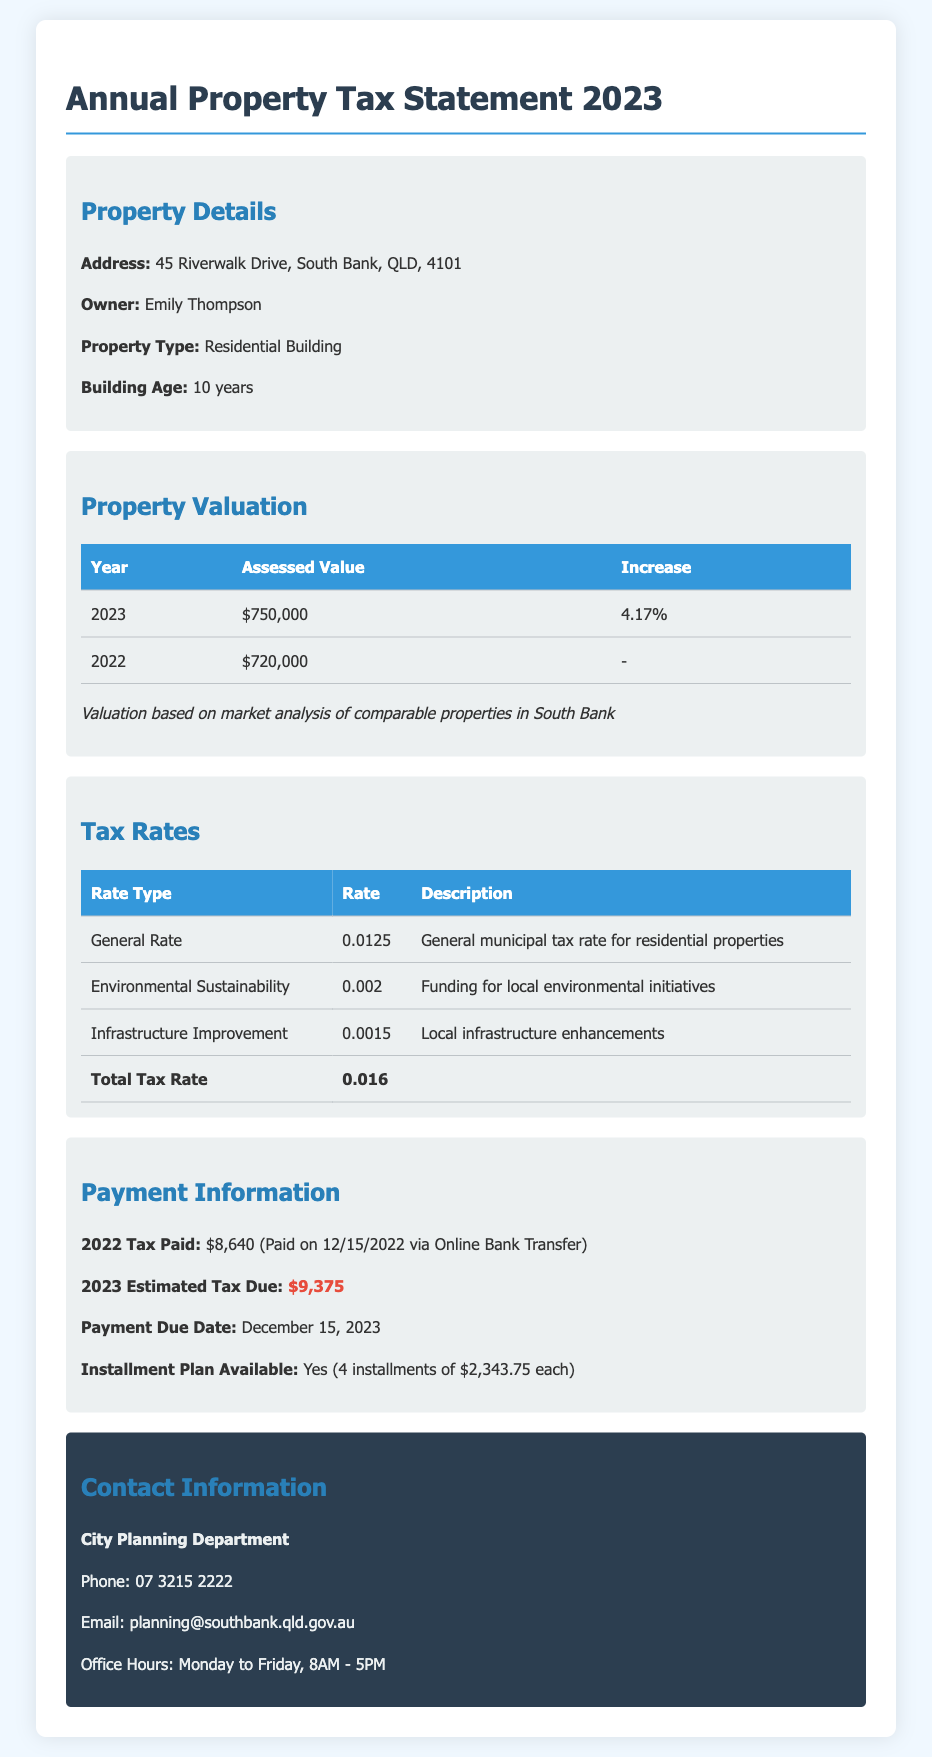What is the address of the property? The address is listed in the property details section.
Answer: 45 Riverwalk Drive, South Bank, QLD, 4101 Who is the owner of the property? The owner's name is mentioned in the property details section.
Answer: Emily Thompson What was the assessed value in 2023? The assessed value for 2023 is provided in the valuation table.
Answer: $750,000 What is the total tax rate? The total tax rate is summarized in the tax rates table.
Answer: 0.016 What was the 2022 tax paid amount? The tax paid amount for the year 2022 is specified in the payment history section.
Answer: $8,640 When is the payment due date for 2023? The payment due date for the 2023 tax is noted in the payment history section.
Answer: December 15, 2023 How many installments are available for the payment plan? The number of installments available for the payment plan is indicated in the payment history section.
Answer: 4 installments What percentage increase was noted in the property valuation from 2022 to 2023? The increase percentage from the valuation section gives this information.
Answer: 4.17% What type of property is listed on the document? The property type is found in the property details section.
Answer: Residential Building 